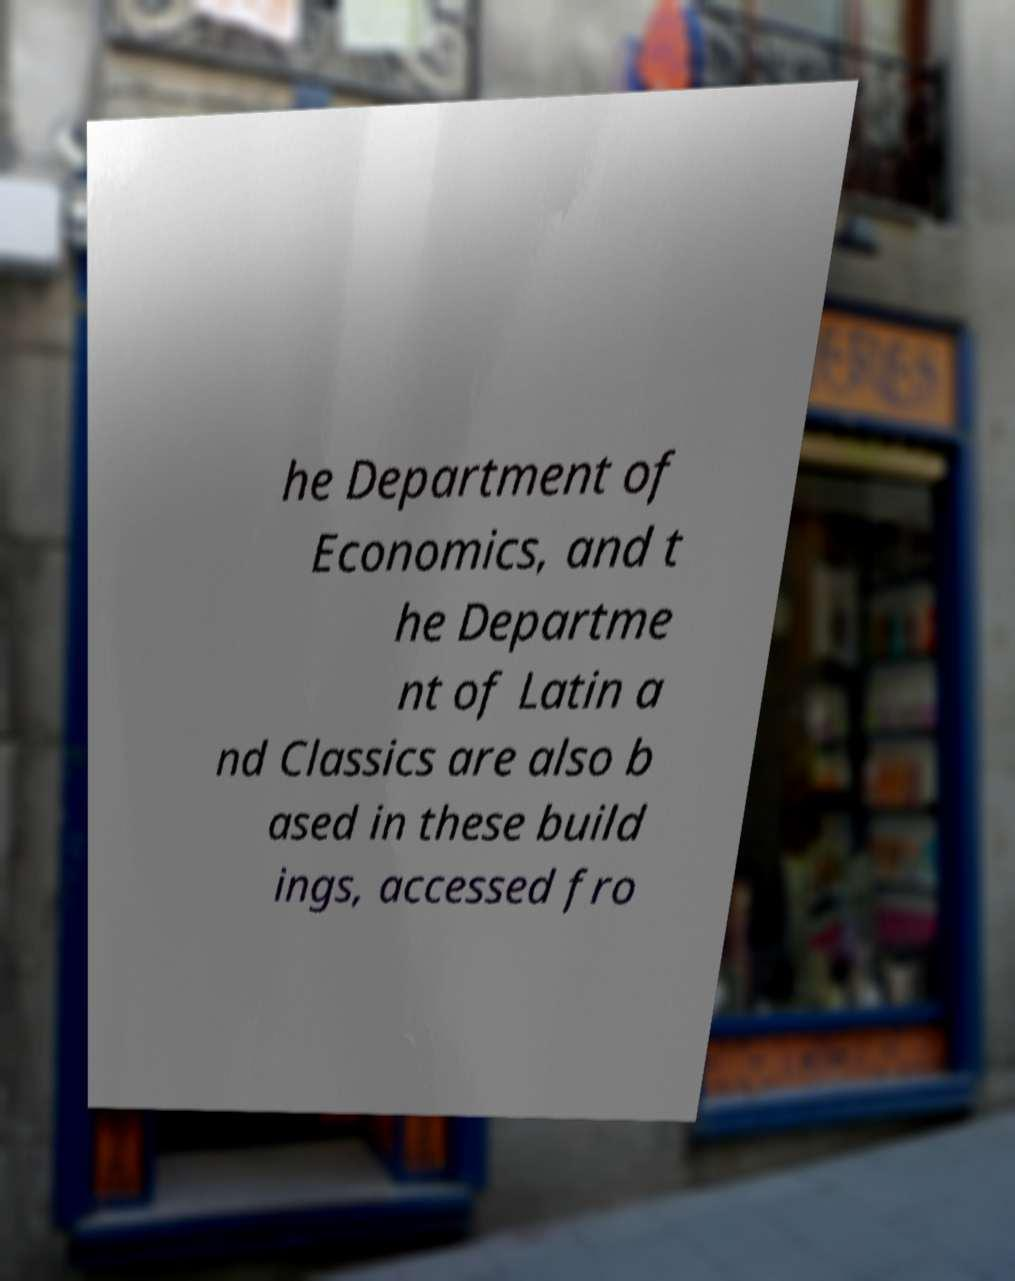Could you assist in decoding the text presented in this image and type it out clearly? he Department of Economics, and t he Departme nt of Latin a nd Classics are also b ased in these build ings, accessed fro 